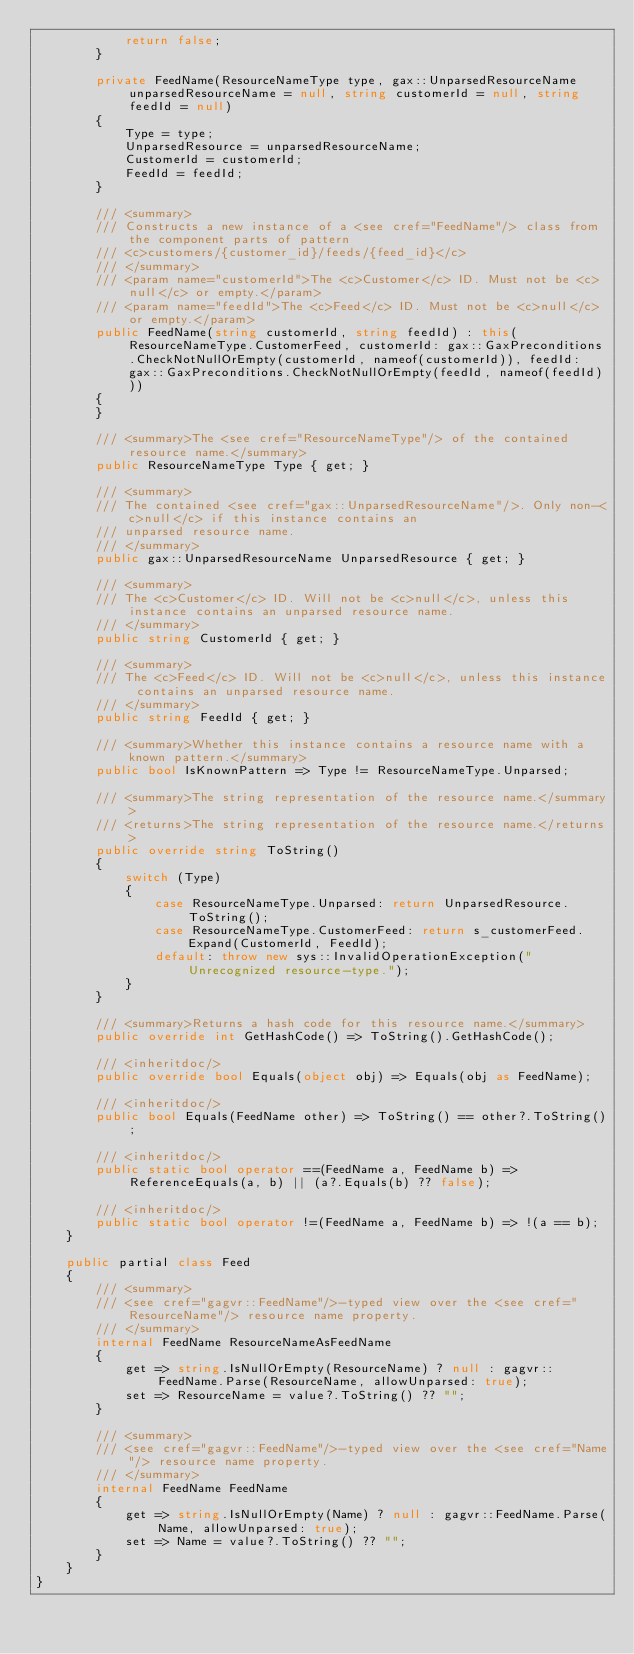<code> <loc_0><loc_0><loc_500><loc_500><_C#_>            return false;
        }

        private FeedName(ResourceNameType type, gax::UnparsedResourceName unparsedResourceName = null, string customerId = null, string feedId = null)
        {
            Type = type;
            UnparsedResource = unparsedResourceName;
            CustomerId = customerId;
            FeedId = feedId;
        }

        /// <summary>
        /// Constructs a new instance of a <see cref="FeedName"/> class from the component parts of pattern
        /// <c>customers/{customer_id}/feeds/{feed_id}</c>
        /// </summary>
        /// <param name="customerId">The <c>Customer</c> ID. Must not be <c>null</c> or empty.</param>
        /// <param name="feedId">The <c>Feed</c> ID. Must not be <c>null</c> or empty.</param>
        public FeedName(string customerId, string feedId) : this(ResourceNameType.CustomerFeed, customerId: gax::GaxPreconditions.CheckNotNullOrEmpty(customerId, nameof(customerId)), feedId: gax::GaxPreconditions.CheckNotNullOrEmpty(feedId, nameof(feedId)))
        {
        }

        /// <summary>The <see cref="ResourceNameType"/> of the contained resource name.</summary>
        public ResourceNameType Type { get; }

        /// <summary>
        /// The contained <see cref="gax::UnparsedResourceName"/>. Only non-<c>null</c> if this instance contains an
        /// unparsed resource name.
        /// </summary>
        public gax::UnparsedResourceName UnparsedResource { get; }

        /// <summary>
        /// The <c>Customer</c> ID. Will not be <c>null</c>, unless this instance contains an unparsed resource name.
        /// </summary>
        public string CustomerId { get; }

        /// <summary>
        /// The <c>Feed</c> ID. Will not be <c>null</c>, unless this instance contains an unparsed resource name.
        /// </summary>
        public string FeedId { get; }

        /// <summary>Whether this instance contains a resource name with a known pattern.</summary>
        public bool IsKnownPattern => Type != ResourceNameType.Unparsed;

        /// <summary>The string representation of the resource name.</summary>
        /// <returns>The string representation of the resource name.</returns>
        public override string ToString()
        {
            switch (Type)
            {
                case ResourceNameType.Unparsed: return UnparsedResource.ToString();
                case ResourceNameType.CustomerFeed: return s_customerFeed.Expand(CustomerId, FeedId);
                default: throw new sys::InvalidOperationException("Unrecognized resource-type.");
            }
        }

        /// <summary>Returns a hash code for this resource name.</summary>
        public override int GetHashCode() => ToString().GetHashCode();

        /// <inheritdoc/>
        public override bool Equals(object obj) => Equals(obj as FeedName);

        /// <inheritdoc/>
        public bool Equals(FeedName other) => ToString() == other?.ToString();

        /// <inheritdoc/>
        public static bool operator ==(FeedName a, FeedName b) => ReferenceEquals(a, b) || (a?.Equals(b) ?? false);

        /// <inheritdoc/>
        public static bool operator !=(FeedName a, FeedName b) => !(a == b);
    }

    public partial class Feed
    {
        /// <summary>
        /// <see cref="gagvr::FeedName"/>-typed view over the <see cref="ResourceName"/> resource name property.
        /// </summary>
        internal FeedName ResourceNameAsFeedName
        {
            get => string.IsNullOrEmpty(ResourceName) ? null : gagvr::FeedName.Parse(ResourceName, allowUnparsed: true);
            set => ResourceName = value?.ToString() ?? "";
        }

        /// <summary>
        /// <see cref="gagvr::FeedName"/>-typed view over the <see cref="Name"/> resource name property.
        /// </summary>
        internal FeedName FeedName
        {
            get => string.IsNullOrEmpty(Name) ? null : gagvr::FeedName.Parse(Name, allowUnparsed: true);
            set => Name = value?.ToString() ?? "";
        }
    }
}
</code> 